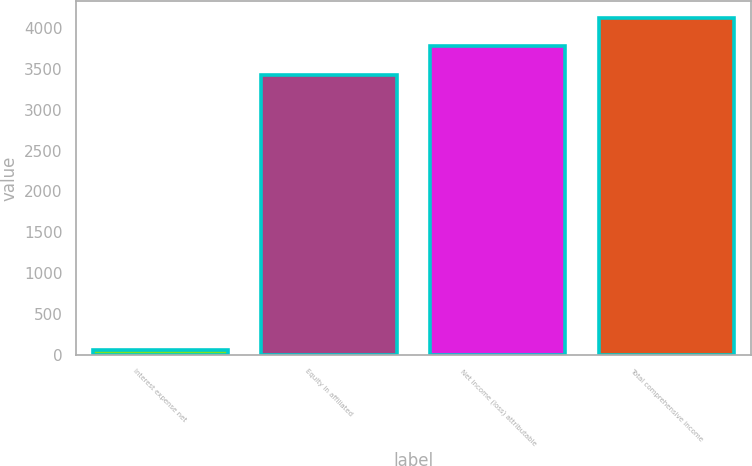<chart> <loc_0><loc_0><loc_500><loc_500><bar_chart><fcel>Interest expense net<fcel>Equity in affiliated<fcel>Net income (loss) attributable<fcel>Total comprehensive income<nl><fcel>59<fcel>3432<fcel>3777<fcel>4122<nl></chart> 